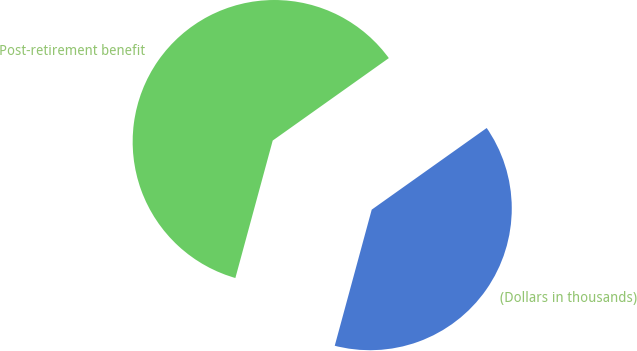<chart> <loc_0><loc_0><loc_500><loc_500><pie_chart><fcel>(Dollars in thousands)<fcel>Post-retirement benefit<nl><fcel>39.05%<fcel>60.95%<nl></chart> 